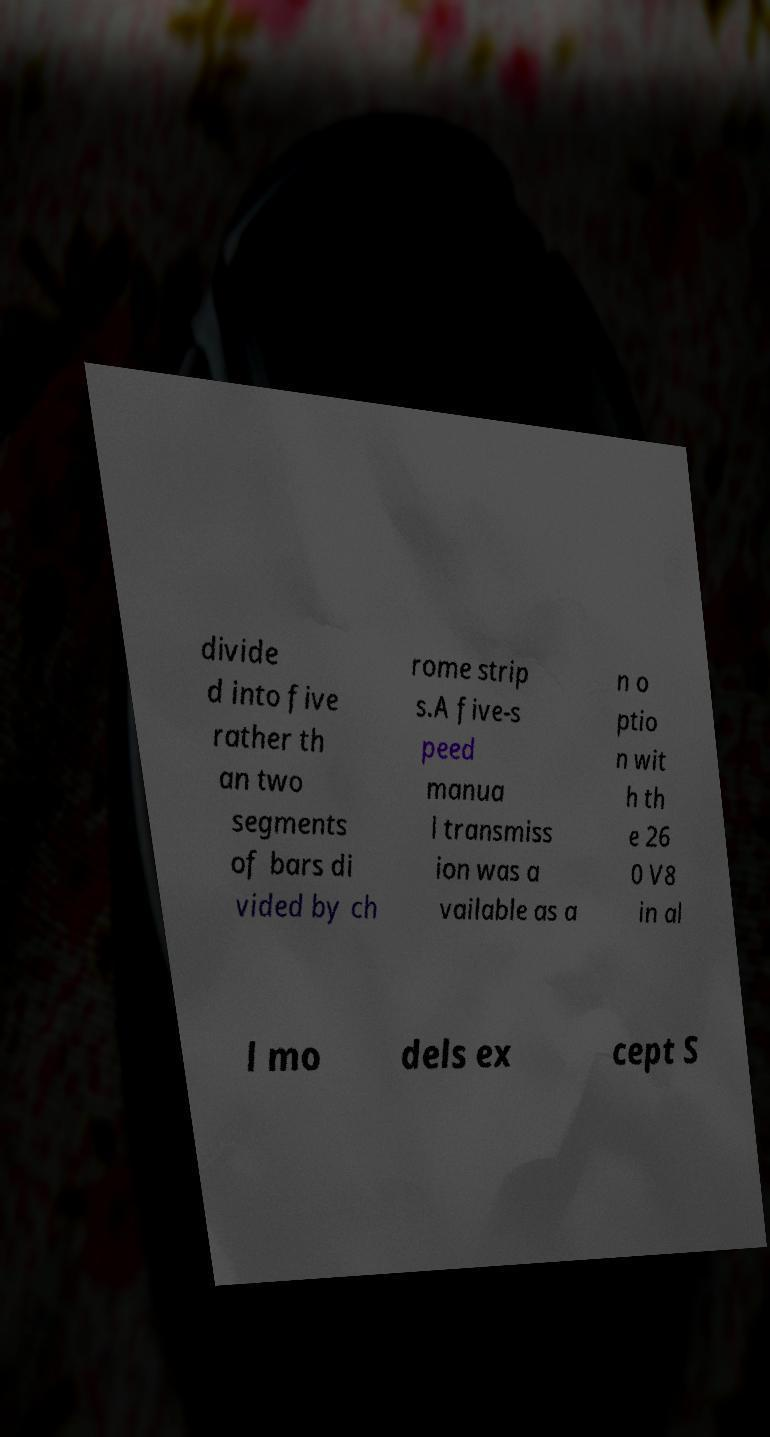There's text embedded in this image that I need extracted. Can you transcribe it verbatim? divide d into five rather th an two segments of bars di vided by ch rome strip s.A five-s peed manua l transmiss ion was a vailable as a n o ptio n wit h th e 26 0 V8 in al l mo dels ex cept S 